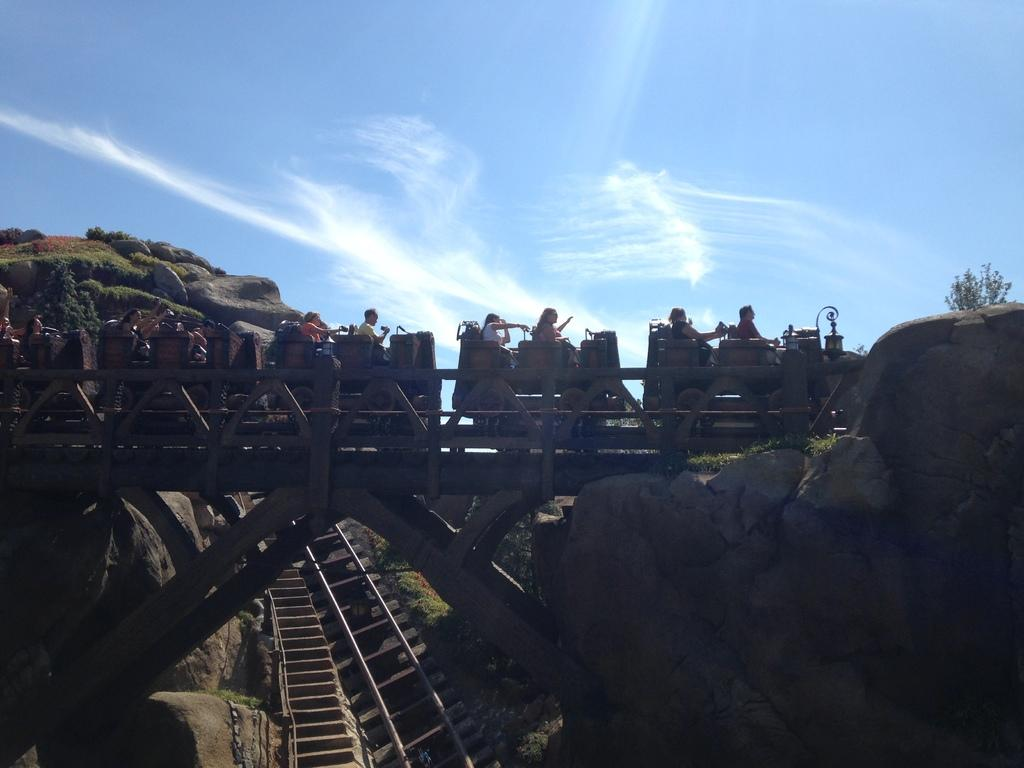What activity are the people in the image participating in? The people in the image are riding on a roller coaster. What can be seen in the background of the image? There are tracks and rocks visible in the background of the image. What type of cap is the roller coaster driver wearing in the image? There is no roller coaster driver visible in the image, and therefore no cap can be observed. 